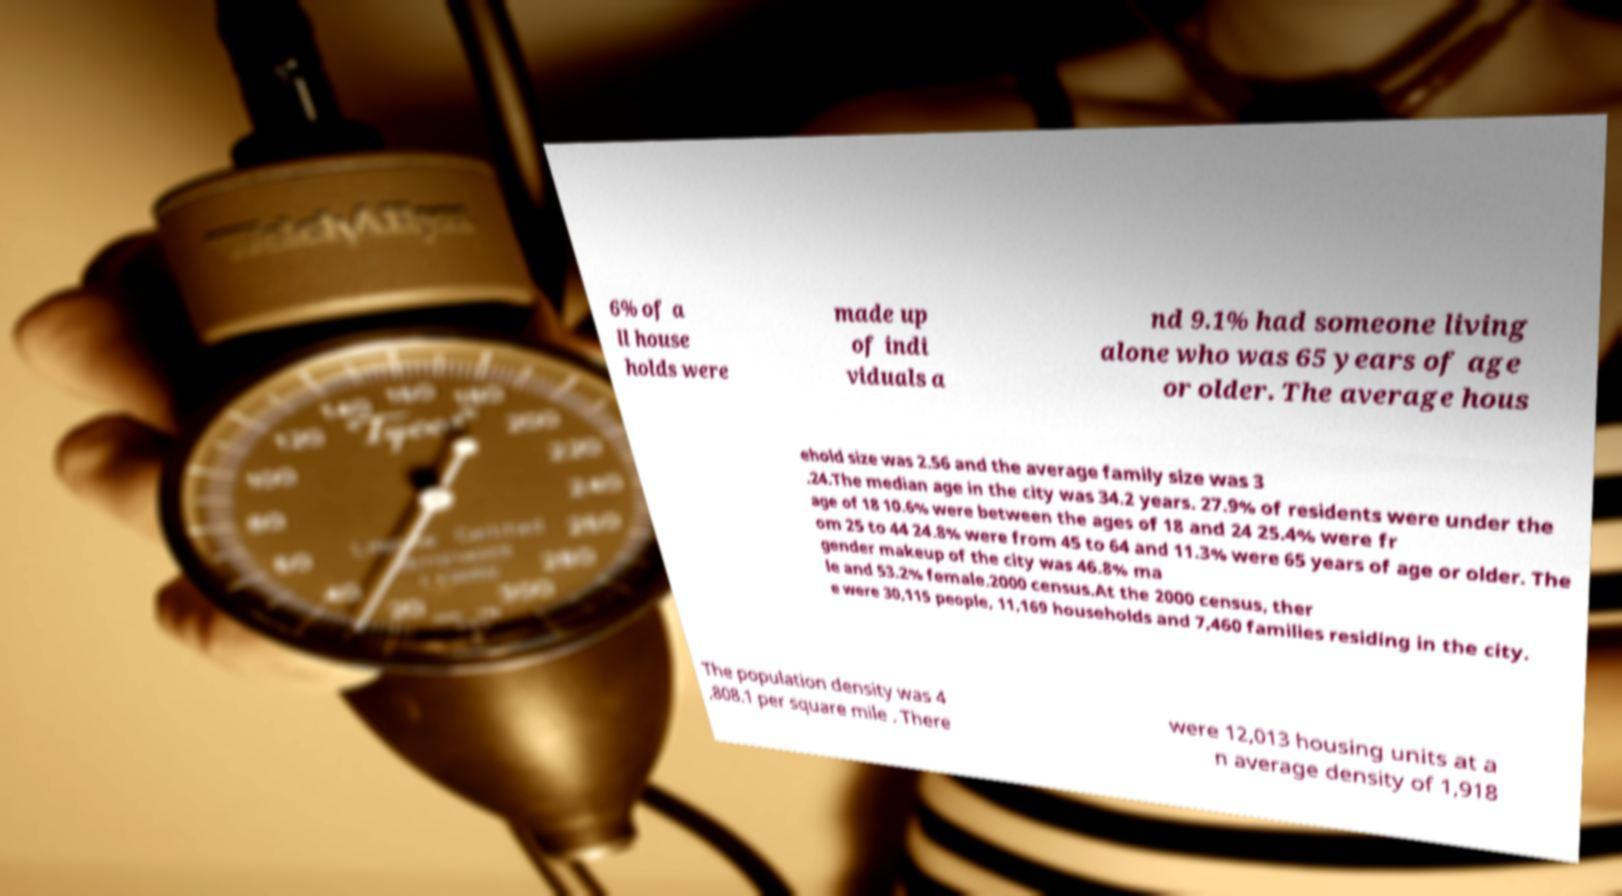Could you assist in decoding the text presented in this image and type it out clearly? 6% of a ll house holds were made up of indi viduals a nd 9.1% had someone living alone who was 65 years of age or older. The average hous ehold size was 2.56 and the average family size was 3 .24.The median age in the city was 34.2 years. 27.9% of residents were under the age of 18 10.6% were between the ages of 18 and 24 25.4% were fr om 25 to 44 24.8% were from 45 to 64 and 11.3% were 65 years of age or older. The gender makeup of the city was 46.8% ma le and 53.2% female.2000 census.At the 2000 census, ther e were 30,115 people, 11,169 households and 7,460 families residing in the city. The population density was 4 ,808.1 per square mile . There were 12,013 housing units at a n average density of 1,918 